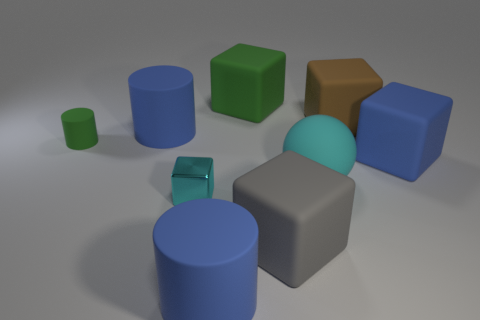Is there anything else that is made of the same material as the tiny cube?
Offer a very short reply. No. There is a cyan thing to the left of the cylinder in front of the gray block; what is its material?
Offer a terse response. Metal. What number of large blocks are both left of the matte sphere and behind the big matte sphere?
Offer a very short reply. 1. What number of other things are the same size as the green cube?
Offer a terse response. 6. Is the shape of the brown object behind the tiny cube the same as the blue object to the right of the big green rubber cube?
Ensure brevity in your answer.  Yes. There is a cyan sphere; are there any cyan matte spheres on the left side of it?
Provide a short and direct response. No. What is the color of the other tiny object that is the same shape as the gray object?
Give a very brief answer. Cyan. Is there any other thing that is the same shape as the large green thing?
Your response must be concise. Yes. What is the material of the cyan thing on the left side of the sphere?
Offer a terse response. Metal. The shiny object that is the same shape as the large brown matte thing is what size?
Provide a succinct answer. Small. 